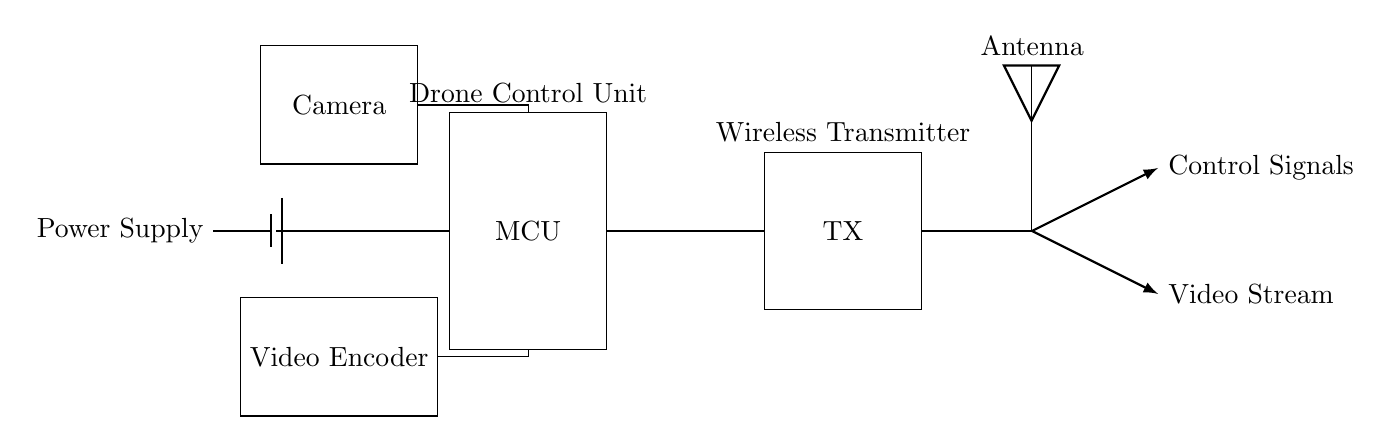What is the main component for controlling the drone? The main component for controlling the drone is the microcontroller, labeled as "MCU" in the diagram. This component is crucial for managing the drone's operations and executes the software needed for flight control.
Answer: MCU What type of signals does the antenna transmit? The antenna transmits two types of signals, control signals for piloting the drone and video stream signals for transmitting the live feed from the camera. These signals are indicated by arrows pointing away from the antenna labeled as such.
Answer: Control Signals and Video Stream What component is responsible for encoding the video? The video encoder, shown as "Video Encoder" in the diagram, is responsible for processing and compressing the video feed from the camera before it is transmitted. This is crucial because it ensures efficient use of bandwidth during live streaming.
Answer: Video Encoder How is power supplied to the circuit? Power is supplied to the circuit from a battery, indicated by a battery symbol connecting to the microcontroller. This battery provides the necessary energy to operate the entire system, including the camera, transmitter, and microcontroller.
Answer: Battery What is the role of the camera in the circuit? The role of the camera in the circuit is to capture live video footage, which is then processed by the video encoder for transmission. The camera feeds into the microcontroller, which coordinates the video data flowing to the encoder for streaming.
Answer: Capture live video Which component connects the microcontroller and the transmitter? The microcontroller is directly connected to the transmitter. This connection indicates that the microcontroller sends control commands to the transmitter to facilitate wireless communication with the drone.
Answer: Transmitter What type of circuit is used for this drone communication system? The circuit is a wireless communication circuit, characterized by the use of a transmitter and antenna for sending and receiving signals without physical connections. This allows for remote control of the drone and live video streaming.
Answer: Wireless communication circuit 